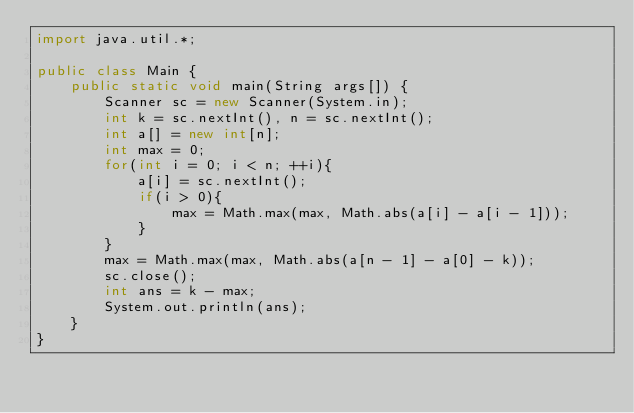Convert code to text. <code><loc_0><loc_0><loc_500><loc_500><_Java_>import java.util.*;

public class Main {
	public static void main(String args[]) {
		Scanner sc = new Scanner(System.in);
		int k = sc.nextInt(), n = sc.nextInt();
		int a[] = new int[n];
		int max = 0;
		for(int i = 0; i < n; ++i){
			a[i] = sc.nextInt();
			if(i > 0){
				max = Math.max(max, Math.abs(a[i] - a[i - 1]));
			}
		}
		max = Math.max(max, Math.abs(a[n - 1] - a[0] - k));
		sc.close();
		int ans = k - max;
		System.out.println(ans);
	}
}
</code> 